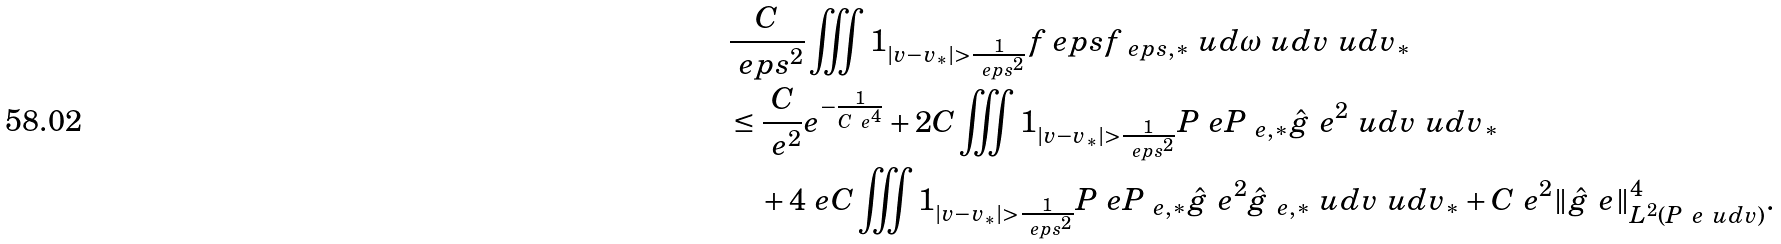Convert formula to latex. <formula><loc_0><loc_0><loc_500><loc_500>& \frac { C } { \ e p s ^ { 2 } } \iiint \mathbb { m } { 1 } _ { | v - v _ { * } | > \frac { 1 } { \ e p s ^ { 2 } } } f _ { \ } e p s f _ { \ e p s , * } \ u d \omega \ u d v \ u d v _ { * } \\ & \leq \frac { C } { \ e ^ { 2 } } e ^ { - \frac { 1 } { C \ e ^ { 4 } } } + 2 C \iiint \mathbb { m } { 1 } _ { | v - v _ { * } | > \frac { 1 } { \ e p s ^ { 2 } } } P _ { \ } e P _ { \ e , * } \hat { g } _ { \ } e ^ { 2 } \ u d v \ u d v _ { * } \\ & \quad + 4 \ e C \iiint \mathbb { m } { 1 } _ { | v - v _ { * } | > \frac { 1 } { \ e p s ^ { 2 } } } P _ { \ } e P _ { \ e , * } \hat { g } _ { \ } e ^ { 2 } \hat { g } _ { \ e , * } \ u d v \ u d v _ { * } + C \ e ^ { 2 } \| \hat { g } _ { \ } e \| _ { L ^ { 2 } ( P _ { \ } e \ u d v ) } ^ { 4 } .</formula> 